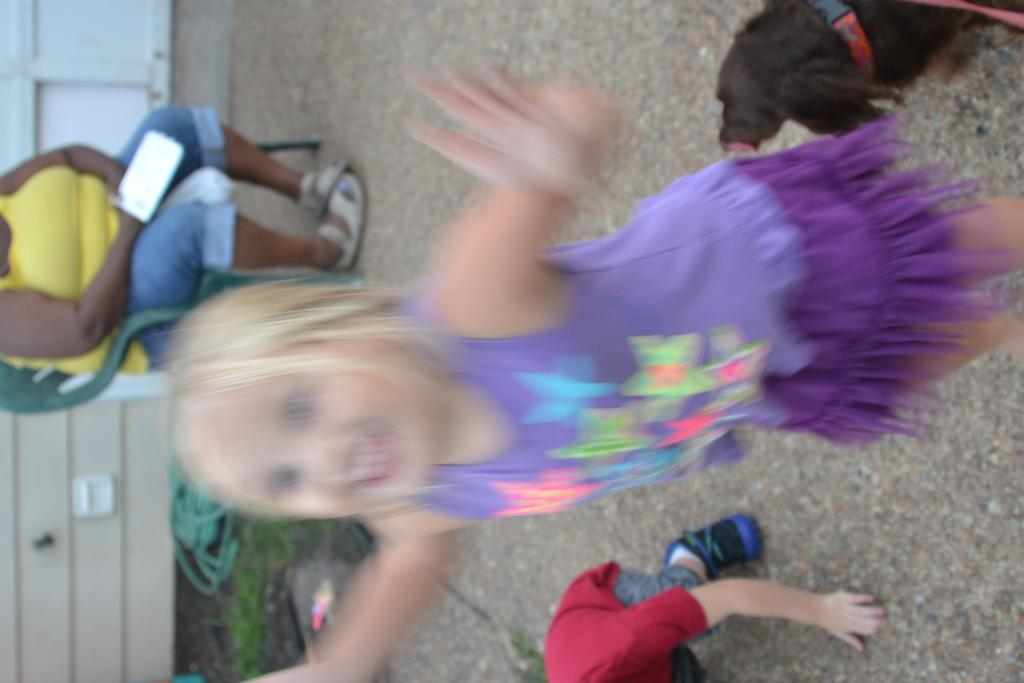What is the quality of the image? The image is blurry. How many children are in the image? There are 2 children in the image. What type of animal is present in the image? There is a black dog in the image. What is the woman doing in the image? The woman is sitting on a chair in the image. What can be seen in the background of the image? There is a path visible in the image. What type of spark can be seen during the feast in the image? There is no feast or spark present in the image. What type of house is visible in the image? There is no house visible in the image. 